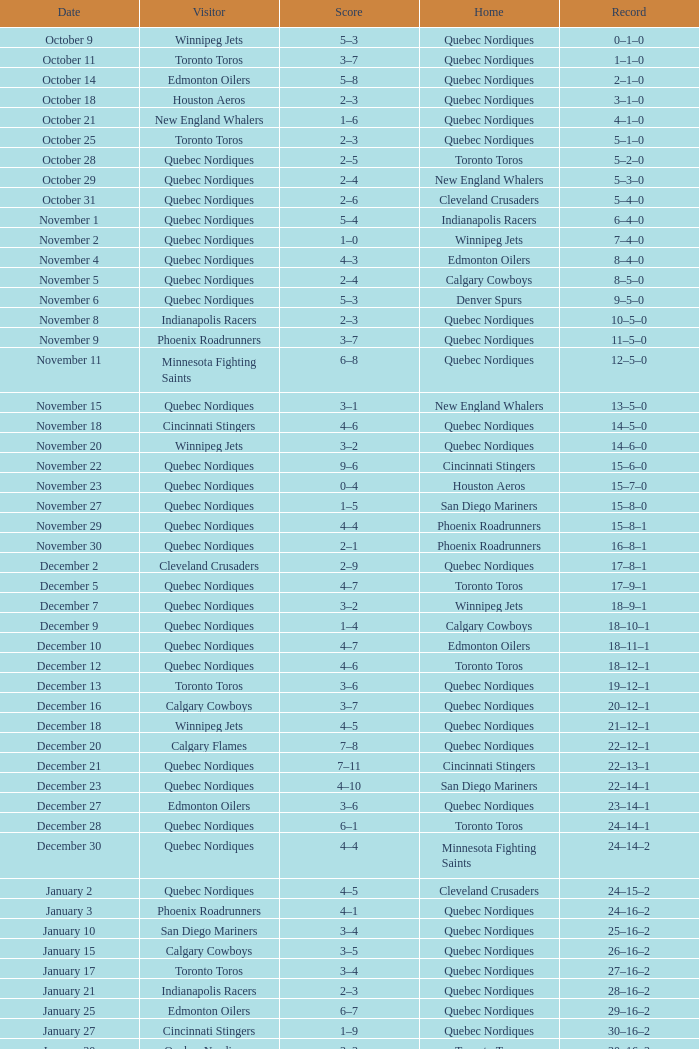Could you parse the entire table? {'header': ['Date', 'Visitor', 'Score', 'Home', 'Record'], 'rows': [['October 9', 'Winnipeg Jets', '5–3', 'Quebec Nordiques', '0–1–0'], ['October 11', 'Toronto Toros', '3–7', 'Quebec Nordiques', '1–1–0'], ['October 14', 'Edmonton Oilers', '5–8', 'Quebec Nordiques', '2–1–0'], ['October 18', 'Houston Aeros', '2–3', 'Quebec Nordiques', '3–1–0'], ['October 21', 'New England Whalers', '1–6', 'Quebec Nordiques', '4–1–0'], ['October 25', 'Toronto Toros', '2–3', 'Quebec Nordiques', '5–1–0'], ['October 28', 'Quebec Nordiques', '2–5', 'Toronto Toros', '5–2–0'], ['October 29', 'Quebec Nordiques', '2–4', 'New England Whalers', '5–3–0'], ['October 31', 'Quebec Nordiques', '2–6', 'Cleveland Crusaders', '5–4–0'], ['November 1', 'Quebec Nordiques', '5–4', 'Indianapolis Racers', '6–4–0'], ['November 2', 'Quebec Nordiques', '1–0', 'Winnipeg Jets', '7–4–0'], ['November 4', 'Quebec Nordiques', '4–3', 'Edmonton Oilers', '8–4–0'], ['November 5', 'Quebec Nordiques', '2–4', 'Calgary Cowboys', '8–5–0'], ['November 6', 'Quebec Nordiques', '5–3', 'Denver Spurs', '9–5–0'], ['November 8', 'Indianapolis Racers', '2–3', 'Quebec Nordiques', '10–5–0'], ['November 9', 'Phoenix Roadrunners', '3–7', 'Quebec Nordiques', '11–5–0'], ['November 11', 'Minnesota Fighting Saints', '6–8', 'Quebec Nordiques', '12–5–0'], ['November 15', 'Quebec Nordiques', '3–1', 'New England Whalers', '13–5–0'], ['November 18', 'Cincinnati Stingers', '4–6', 'Quebec Nordiques', '14–5–0'], ['November 20', 'Winnipeg Jets', '3–2', 'Quebec Nordiques', '14–6–0'], ['November 22', 'Quebec Nordiques', '9–6', 'Cincinnati Stingers', '15–6–0'], ['November 23', 'Quebec Nordiques', '0–4', 'Houston Aeros', '15–7–0'], ['November 27', 'Quebec Nordiques', '1–5', 'San Diego Mariners', '15–8–0'], ['November 29', 'Quebec Nordiques', '4–4', 'Phoenix Roadrunners', '15–8–1'], ['November 30', 'Quebec Nordiques', '2–1', 'Phoenix Roadrunners', '16–8–1'], ['December 2', 'Cleveland Crusaders', '2–9', 'Quebec Nordiques', '17–8–1'], ['December 5', 'Quebec Nordiques', '4–7', 'Toronto Toros', '17–9–1'], ['December 7', 'Quebec Nordiques', '3–2', 'Winnipeg Jets', '18–9–1'], ['December 9', 'Quebec Nordiques', '1–4', 'Calgary Cowboys', '18–10–1'], ['December 10', 'Quebec Nordiques', '4–7', 'Edmonton Oilers', '18–11–1'], ['December 12', 'Quebec Nordiques', '4–6', 'Toronto Toros', '18–12–1'], ['December 13', 'Toronto Toros', '3–6', 'Quebec Nordiques', '19–12–1'], ['December 16', 'Calgary Cowboys', '3–7', 'Quebec Nordiques', '20–12–1'], ['December 18', 'Winnipeg Jets', '4–5', 'Quebec Nordiques', '21–12–1'], ['December 20', 'Calgary Flames', '7–8', 'Quebec Nordiques', '22–12–1'], ['December 21', 'Quebec Nordiques', '7–11', 'Cincinnati Stingers', '22–13–1'], ['December 23', 'Quebec Nordiques', '4–10', 'San Diego Mariners', '22–14–1'], ['December 27', 'Edmonton Oilers', '3–6', 'Quebec Nordiques', '23–14–1'], ['December 28', 'Quebec Nordiques', '6–1', 'Toronto Toros', '24–14–1'], ['December 30', 'Quebec Nordiques', '4–4', 'Minnesota Fighting Saints', '24–14–2'], ['January 2', 'Quebec Nordiques', '4–5', 'Cleveland Crusaders', '24–15–2'], ['January 3', 'Phoenix Roadrunners', '4–1', 'Quebec Nordiques', '24–16–2'], ['January 10', 'San Diego Mariners', '3–4', 'Quebec Nordiques', '25–16–2'], ['January 15', 'Calgary Cowboys', '3–5', 'Quebec Nordiques', '26–16–2'], ['January 17', 'Toronto Toros', '3–4', 'Quebec Nordiques', '27–16–2'], ['January 21', 'Indianapolis Racers', '2–3', 'Quebec Nordiques', '28–16–2'], ['January 25', 'Edmonton Oilers', '6–7', 'Quebec Nordiques', '29–16–2'], ['January 27', 'Cincinnati Stingers', '1–9', 'Quebec Nordiques', '30–16–2'], ['January 30', 'Quebec Nordiques', '3–3', 'Toronto Toros', '30–16–3'], ['January 31', 'Toronto Toros', '4–8', 'Quebec Nordiques', '31–16–3'], ['February 3', 'Winnipeg Jets', '4–5', 'Quebec Nordiques', '32–16–3'], ['February 5', 'Quebec Nordiques', '2–4', 'Indianapolis Racers', '32–17–3'], ['February 7', 'Quebec Nordiques', '4–4', 'Calgary Cowboys', '32–17–4'], ['February 8', 'Quebec Nordiques', '5–4', 'Edmonton Oilers', '33–17–4'], ['February 11', 'Quebec Nordiques', '6–4', 'Winnipeg Jets', '34–17–4'], ['February 12', 'Quebec Nordiques', '4–6', 'Minnesota Fighting Saints', '34–18–4'], ['February 15', 'Quebec Nordiques', '4–2', 'Houston Aeros', '35–18–4'], ['February 17', 'San Diego Mariners', '2–5', 'Quebec Nordiques', '36–18–4'], ['February 22', 'New England Whalers', '0–4', 'Quebec Nordiques', '37–18–4'], ['February 24', 'Houston Aeros', '1–4', 'Quebec Nordiques', '38–18–4'], ['February 28', 'Winnipeg Jets', '4–3', 'Quebec Nordiques', '38–19–4'], ['March 2', 'Quebec Nordiques', '2–5', 'Toronto Toros', '38–20–4'], ['March 4', 'Quebec Nordiques', '1–4', 'Calgary Cowboys', '38–21–4'], ['March 5', 'Quebec Nordiques', '5–4', 'Edmonton Oilers', '39–21–4'], ['March 7', 'Quebec Nordiques', '2–4', 'Edmonton Oilers', '39–22–4'], ['March 9', 'Quebec Nordiques', '4–7', 'Calgary Cowboys', '39–23–4'], ['March 10', 'Quebec Nordiques', '3–10', 'Winnipeg Jets', '39–24–4'], ['March 12', 'Quebec Nordiques', '10–8', 'Winnipeg Jets', '40–24–4'], ['March 14', 'Toronto Toros', '3–1', 'Quebec Nordiques', '40–25–4'], ['March 16', 'New England Whalers', '1–5', 'Quebec Nordiques', '41–25–4'], ['March 19', 'Quebec Nordiques', '4–3', 'Toronto Toros', '42–25–4'], ['March 20', 'Calgary Cowboys', '8–7', 'Quebec Nordiques', '42–26–4'], ['March 21', 'Quebec Nordiques', '6–3', 'Edmonton Oilers', '43–26–4'], ['March 23', 'Cleveland Crusaders', '3–1', 'Quebec Nordiques', '43–27–4'], ['March 25', 'Edmonton Oilers', '5–7', 'Quebec Nordiques', '44–27–4'], ['March 27', 'Calgary Cowboys', '4–6', 'Quebec Nordiques', '45–27–4'], ['March 30', 'Edmonton Oilers', '3–8', 'Quebec Nordiques', '46–27–4'], ['April 1', 'Edmonton Oilers', '2–7', 'Quebec Nordiques', '47–27–4'], ['April 3', 'Toronto Toros', '1–5', 'Quebec Nordiques', '48–27–4'], ['April 4', 'Quebec Nordiques', '5–4', 'Toronto Toros', '49–27–4'], ['April 6', 'Toronto Toros', '6–10', 'Quebec Nordiques', '50–27–4']]} What was the score of the game when the record was 39–21–4? 5–4. 